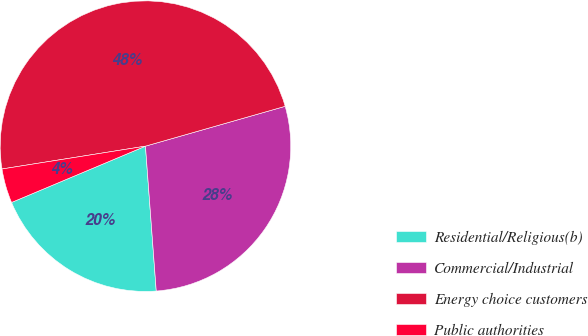<chart> <loc_0><loc_0><loc_500><loc_500><pie_chart><fcel>Residential/Religious(b)<fcel>Commercial/Industrial<fcel>Energy choice customers<fcel>Public authorities<nl><fcel>19.85%<fcel>28.24%<fcel>48.09%<fcel>3.82%<nl></chart> 